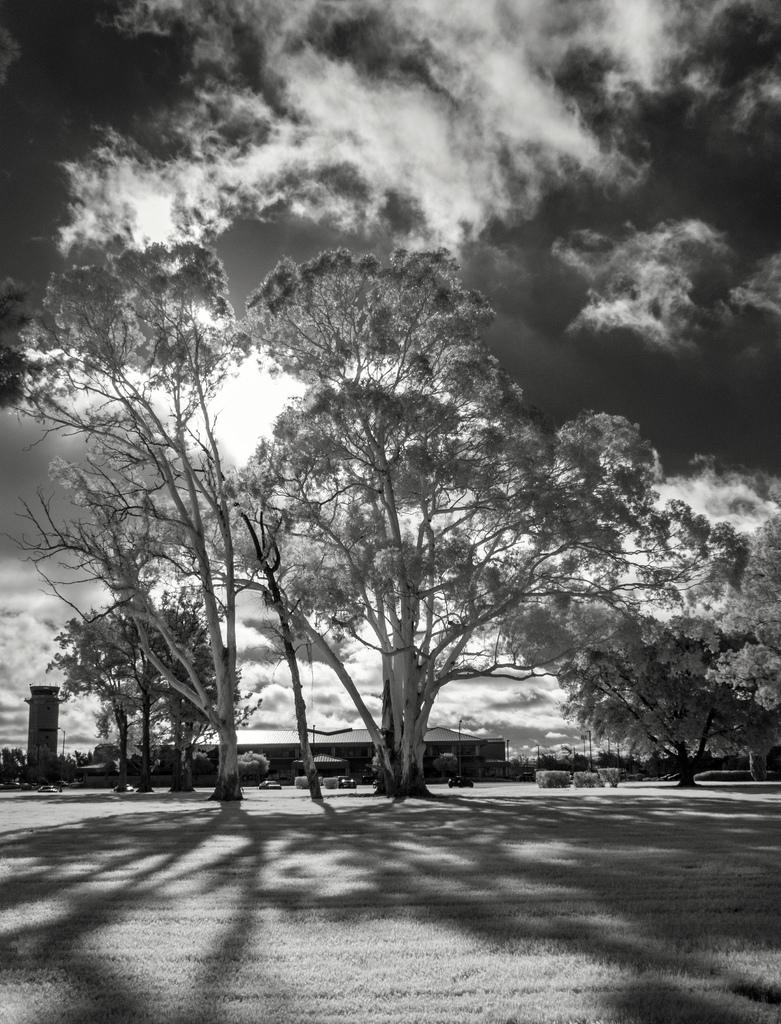What is the main feature of the image? There is a road in the image. What can be seen near the road? There are many trees and a shed near the road. What is visible in the background of the image? There are clouds and the sky visible in the background. How many dogs are sitting on the desk in the image? There is no desk or dogs present in the image. 